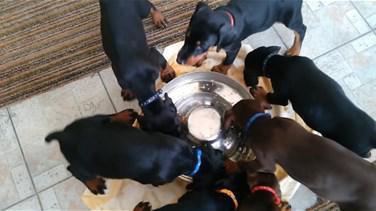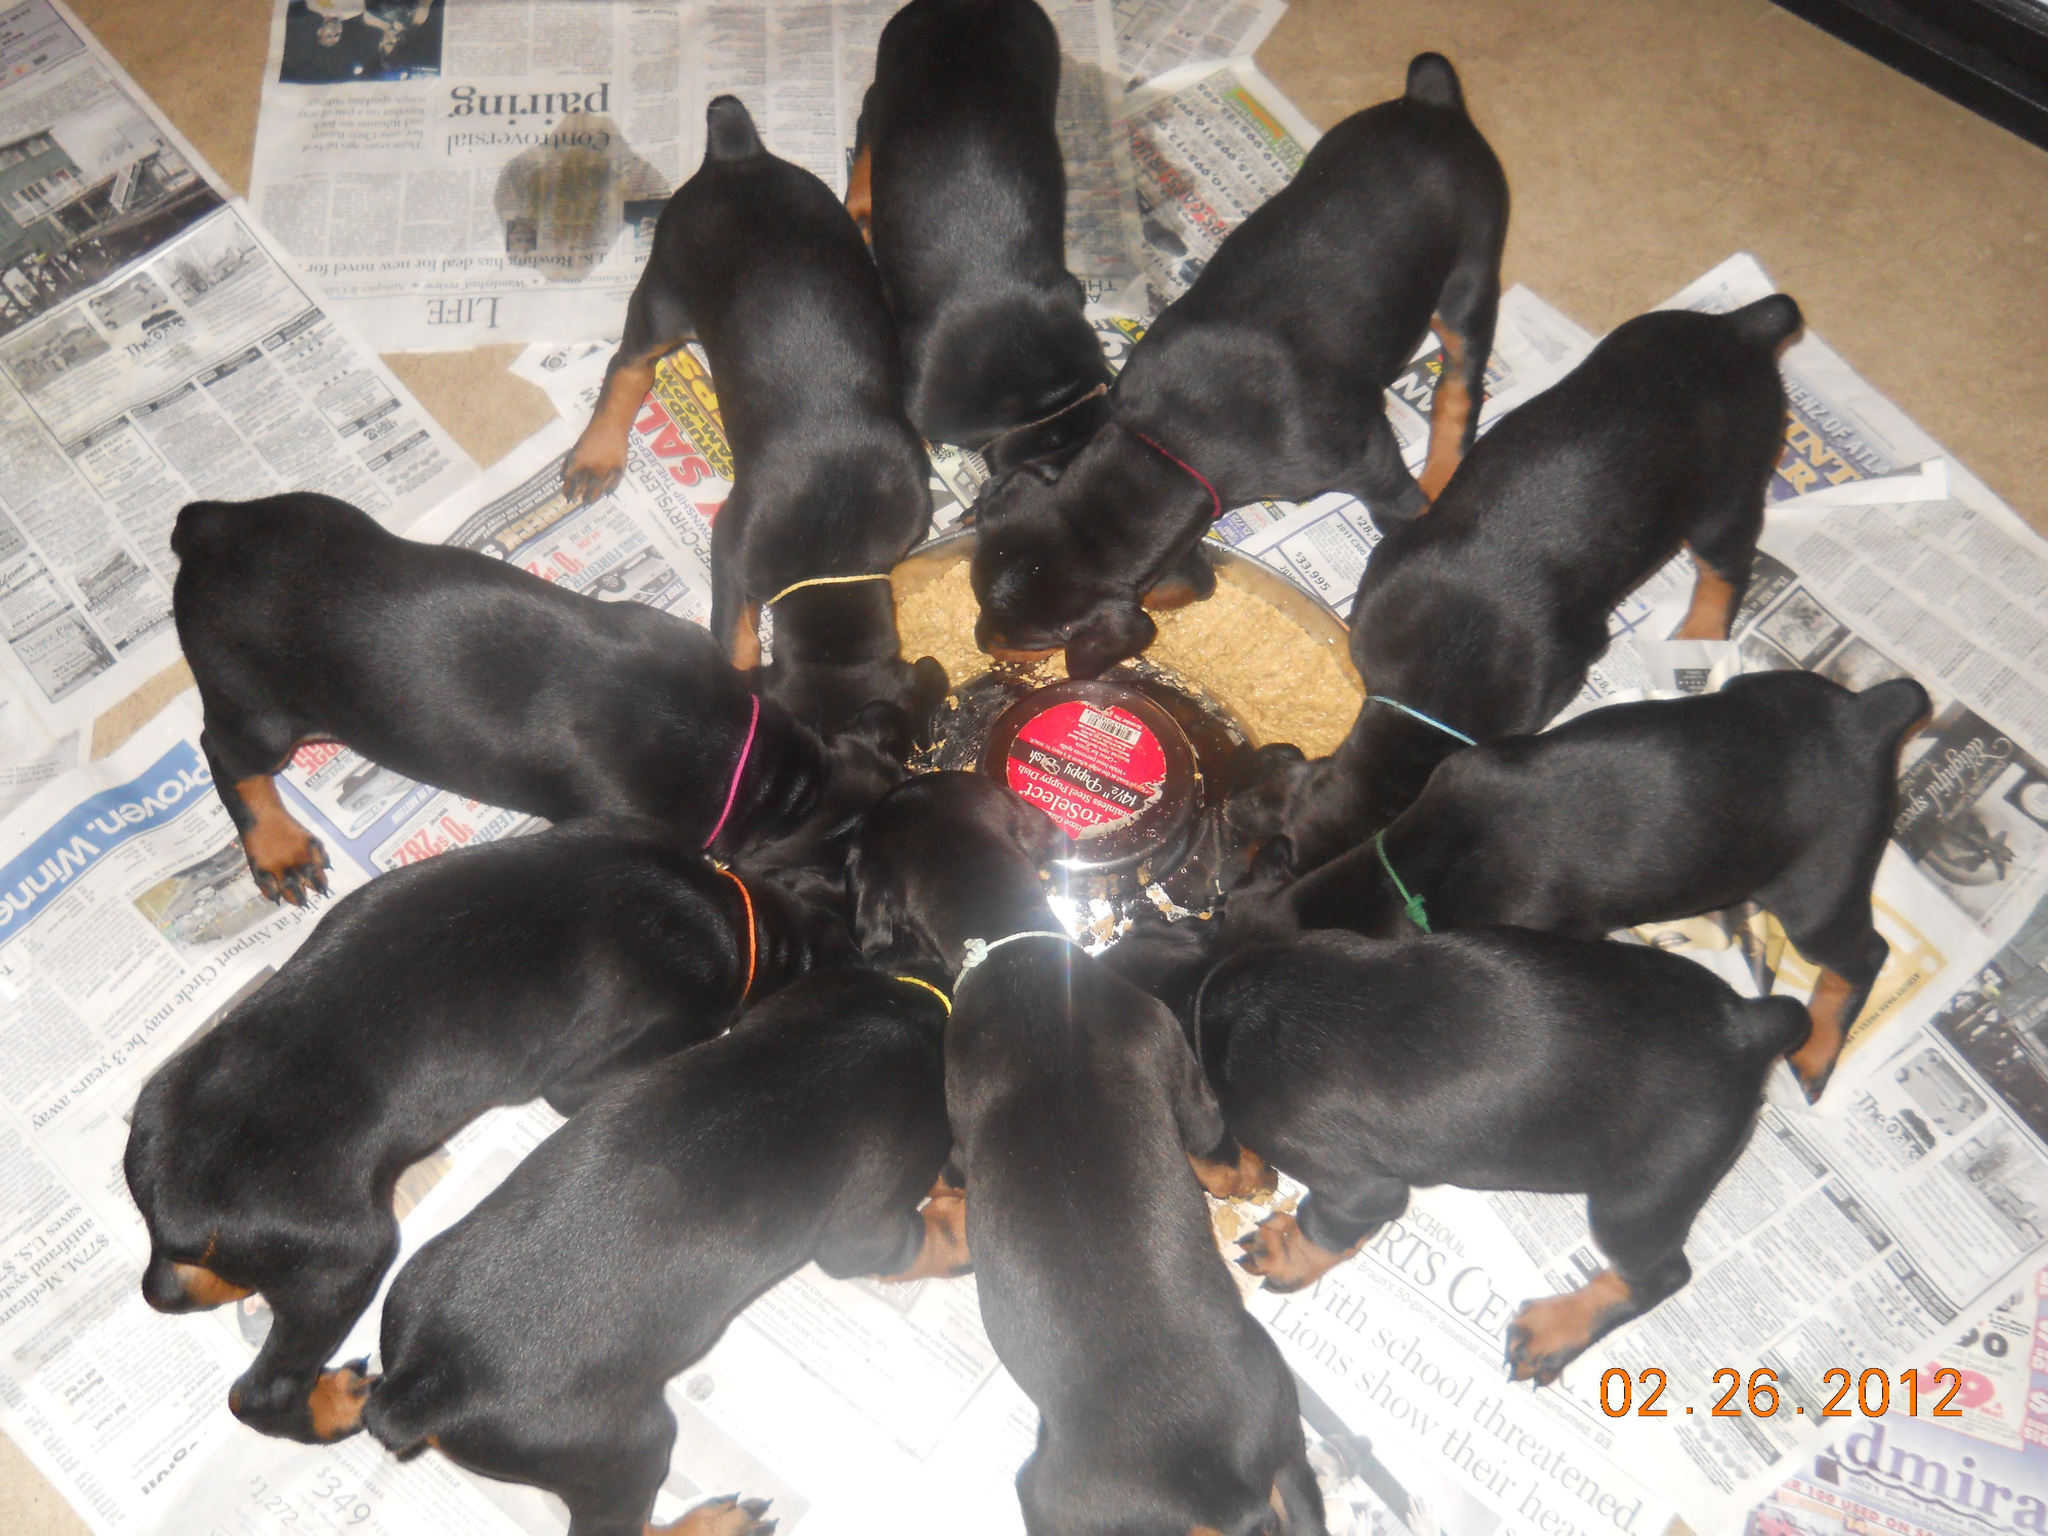The first image is the image on the left, the second image is the image on the right. For the images shown, is this caption "Dogs are eating out of a bowl." true? Answer yes or no. Yes. The first image is the image on the left, the second image is the image on the right. Given the left and right images, does the statement "Multiple puppies are standing around at least part of a round silver bowl shape in at least one image." hold true? Answer yes or no. Yes. 